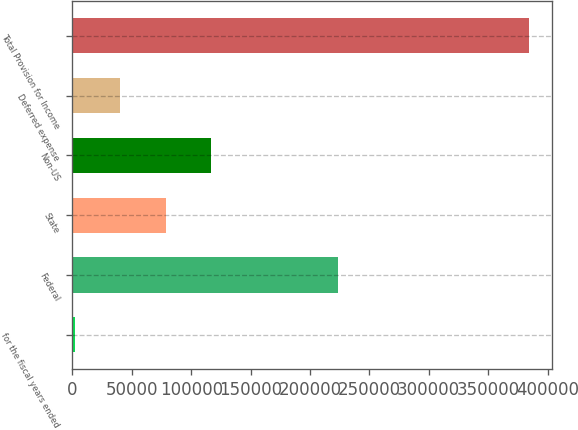Convert chart to OTSL. <chart><loc_0><loc_0><loc_500><loc_500><bar_chart><fcel>for the fiscal years ended<fcel>Federal<fcel>State<fcel>Non-US<fcel>Deferred expense<fcel>Total Provision for Income<nl><fcel>2009<fcel>223600<fcel>78470<fcel>116700<fcel>40239.5<fcel>384314<nl></chart> 